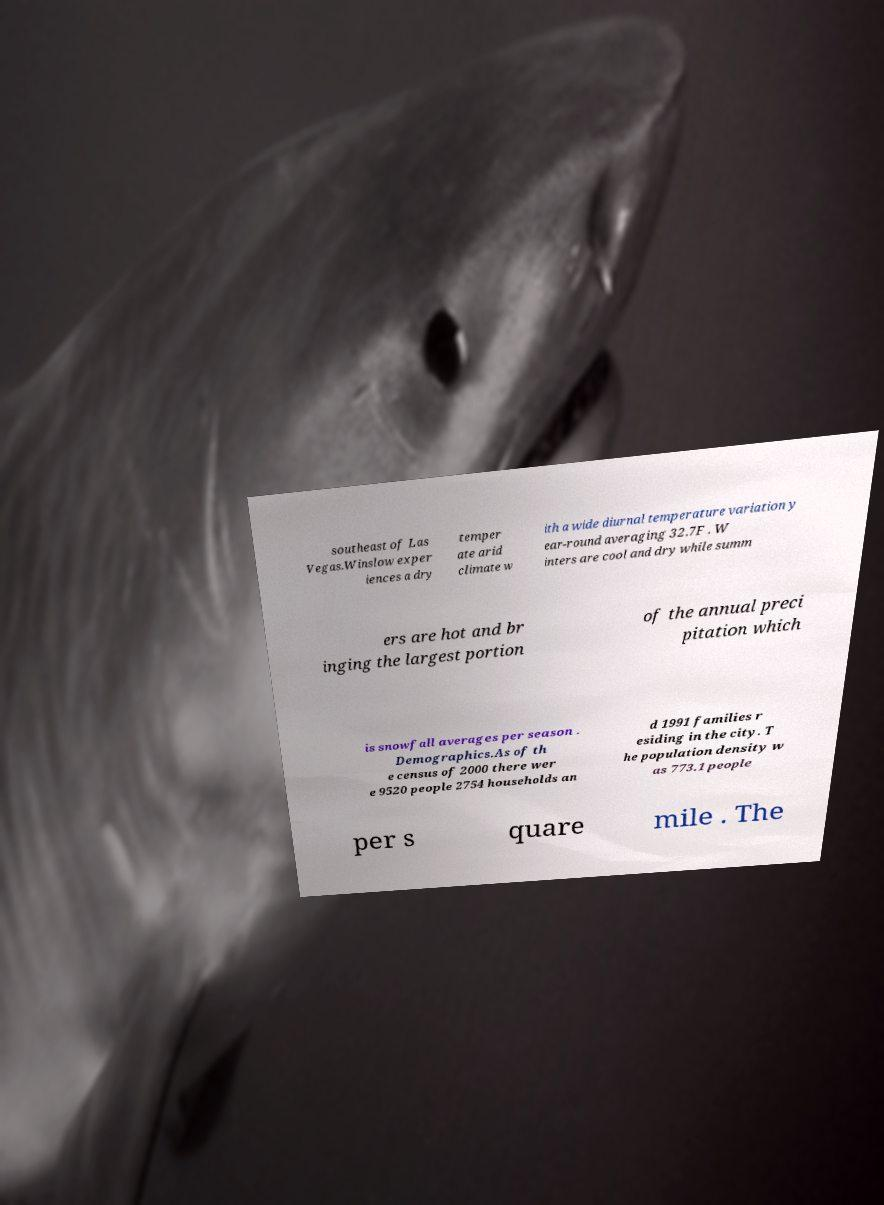For documentation purposes, I need the text within this image transcribed. Could you provide that? southeast of Las Vegas.Winslow exper iences a dry temper ate arid climate w ith a wide diurnal temperature variation y ear-round averaging 32.7F . W inters are cool and dry while summ ers are hot and br inging the largest portion of the annual preci pitation which is snowfall averages per season . Demographics.As of th e census of 2000 there wer e 9520 people 2754 households an d 1991 families r esiding in the city. T he population density w as 773.1 people per s quare mile . The 